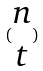Convert formula to latex. <formula><loc_0><loc_0><loc_500><loc_500>( \begin{matrix} n \\ t \end{matrix} )</formula> 